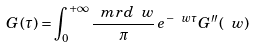<formula> <loc_0><loc_0><loc_500><loc_500>G ( \tau ) = \int _ { 0 } ^ { + \infty } \frac { \ m r { d } \ w } { \pi } \, e ^ { - \ w \tau } G ^ { \prime \prime } ( \ w )</formula> 